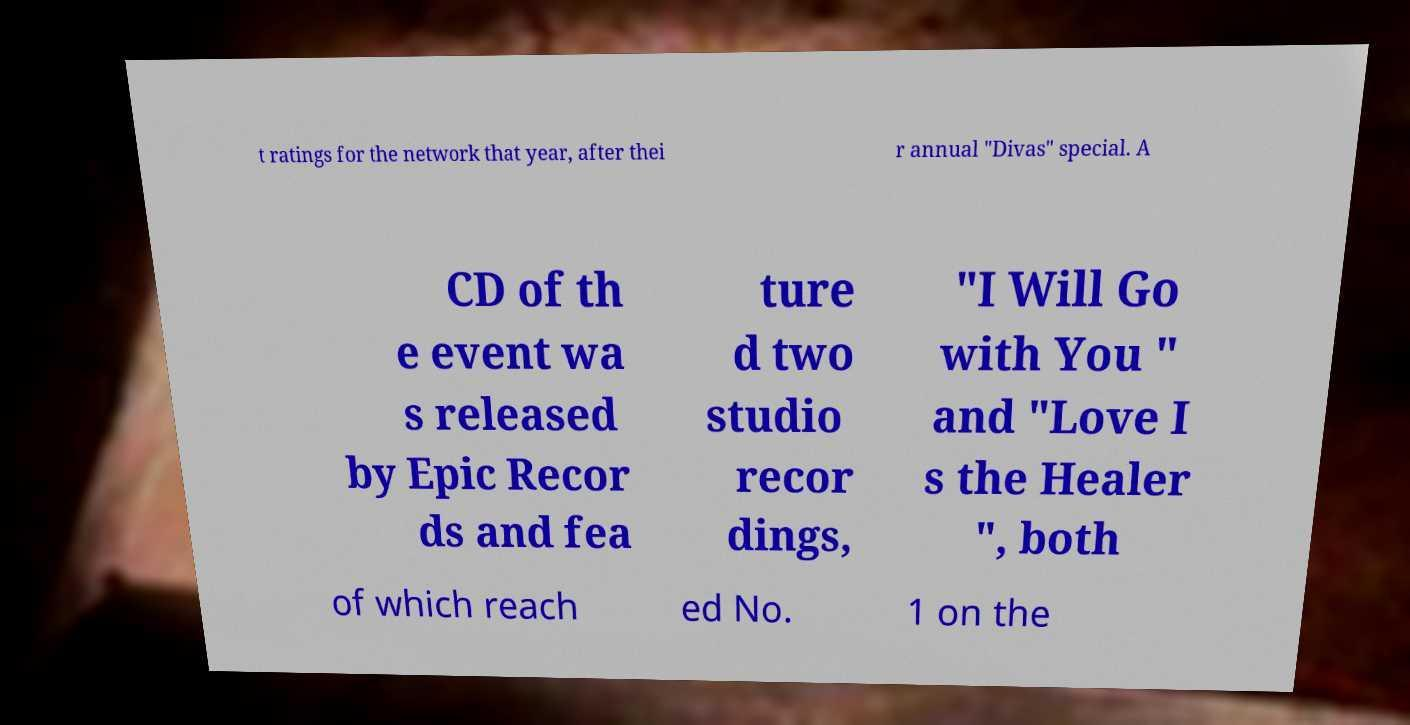Please read and relay the text visible in this image. What does it say? t ratings for the network that year, after thei r annual "Divas" special. A CD of th e event wa s released by Epic Recor ds and fea ture d two studio recor dings, "I Will Go with You " and "Love I s the Healer ", both of which reach ed No. 1 on the 